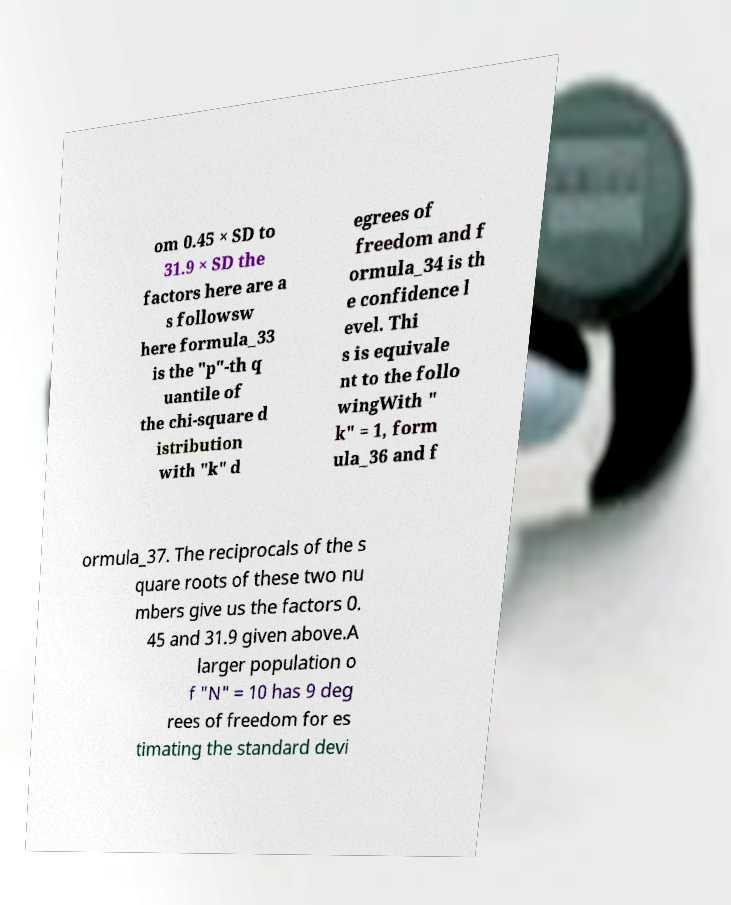Could you extract and type out the text from this image? om 0.45 × SD to 31.9 × SD the factors here are a s followsw here formula_33 is the "p"-th q uantile of the chi-square d istribution with "k" d egrees of freedom and f ormula_34 is th e confidence l evel. Thi s is equivale nt to the follo wingWith " k" = 1, form ula_36 and f ormula_37. The reciprocals of the s quare roots of these two nu mbers give us the factors 0. 45 and 31.9 given above.A larger population o f "N" = 10 has 9 deg rees of freedom for es timating the standard devi 